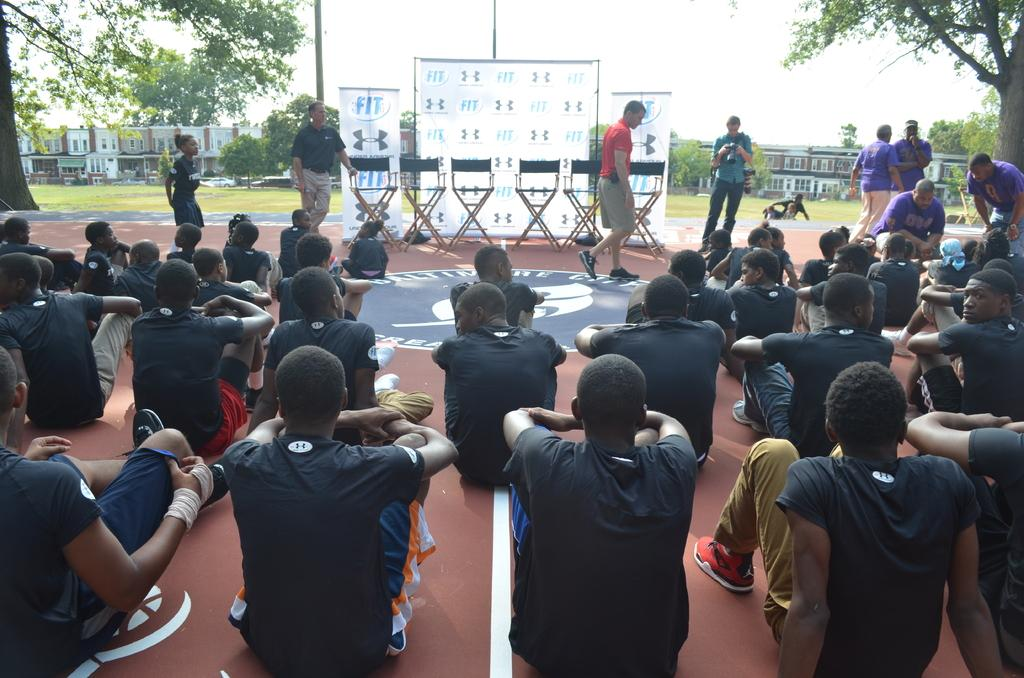What are the people in the image doing? There are people sitting, standing, and walking in the image. What type of furniture is present in the image? Chairs are present in the image. What decorative elements can be seen in the image? Banners are visible in the image. What can be seen in the background of the image? There are trees, buildings, poles, grass, and the sky visible in the background. What type of tooth can be seen in the image? There is no tooth present in the image. How many forks are visible in the image? There are no forks visible in the image. 